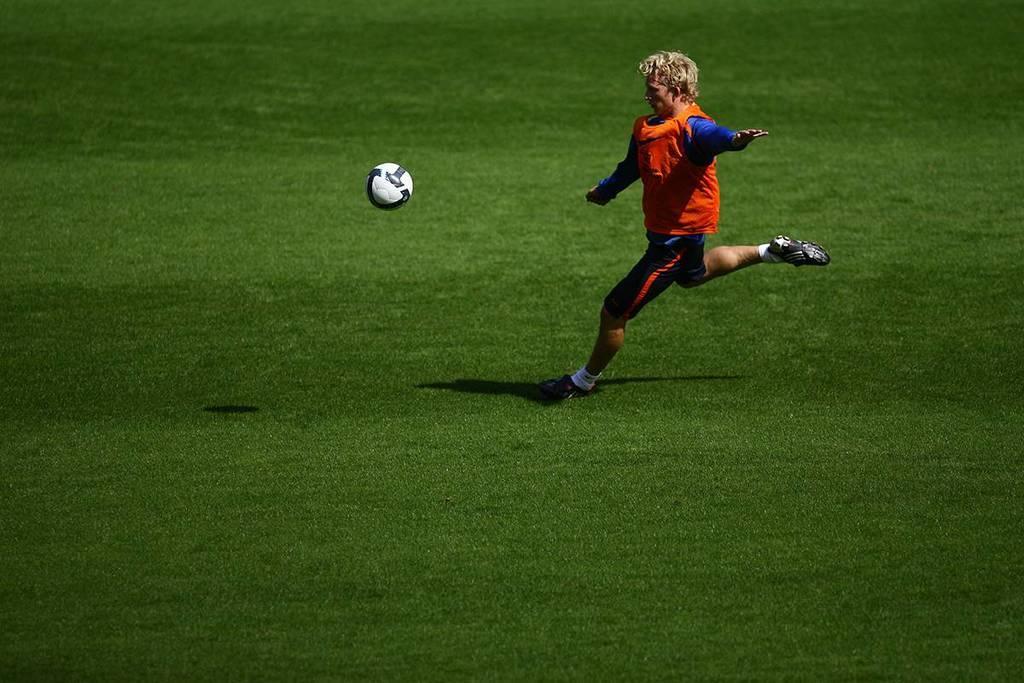Describe this image in one or two sentences. In the picture,a person is playing a football he is running on the ground and the football is flying in the air. 